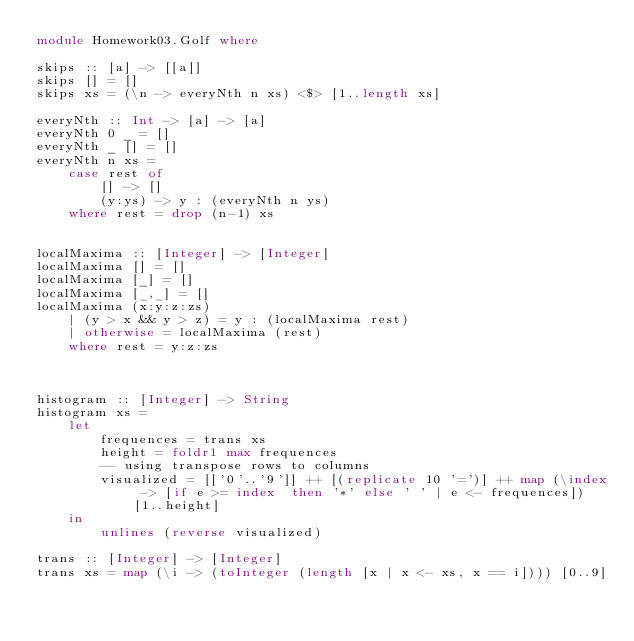Convert code to text. <code><loc_0><loc_0><loc_500><loc_500><_Haskell_>module Homework03.Golf where

skips :: [a] -> [[a]]
skips [] = []
skips xs = (\n -> everyNth n xs) <$> [1..length xs]

everyNth :: Int -> [a] -> [a]
everyNth 0 _ = []
everyNth _ [] = []
everyNth n xs = 
    case rest of 
        [] -> [] 
        (y:ys) -> y : (everyNth n ys)
    where rest = drop (n-1) xs


localMaxima :: [Integer] -> [Integer]
localMaxima [] = []
localMaxima [_] = []
localMaxima [_,_] = []
localMaxima (x:y:z:zs)
    | (y > x && y > z) = y : (localMaxima rest)
    | otherwise = localMaxima (rest)
    where rest = y:z:zs



histogram :: [Integer] -> String
histogram xs = 
    let 
        frequences = trans xs
        height = foldr1 max frequences 
        -- using transpose rows to columns
        visualized = [['0'..'9']] ++ [(replicate 10 '=')] ++ map (\index -> [if e >= index  then '*' else ' ' | e <- frequences]) [1..height]
    in
        unlines (reverse visualized)
        
trans :: [Integer] -> [Integer]
trans xs = map (\i -> (toInteger (length [x | x <- xs, x == i]))) [0..9]</code> 